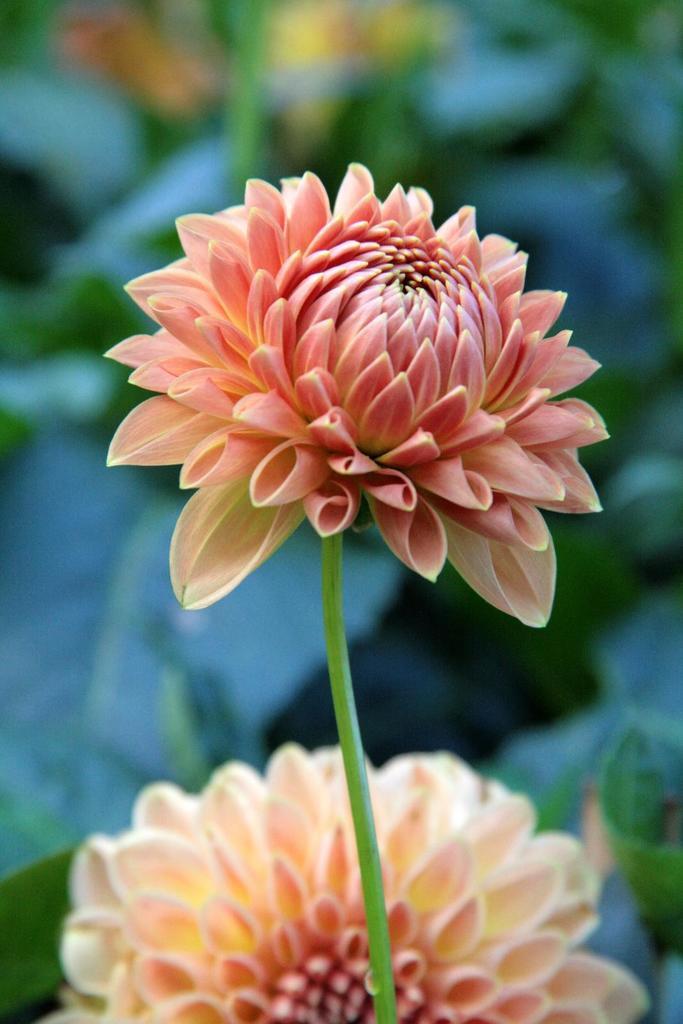Describe this image in one or two sentences. This picture seems to be clicked inside. In the foreground we can see the two flowers and a stem. The background of the image is very blurry and I can see the leaves and a plant. 